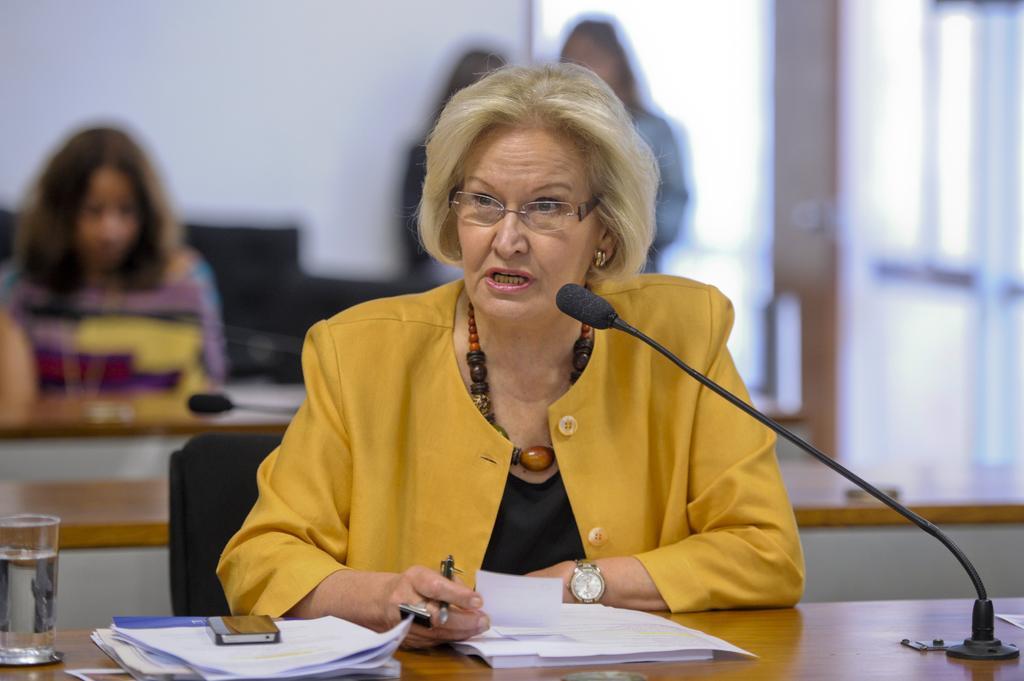How would you summarize this image in a sentence or two? In this image, we can see four persons. The person who is in the middle of the image sitting on chair in front of the table. This table contains papers, glass and mic. There is an another table at the bottom of the image. In the background, image is blurred. 